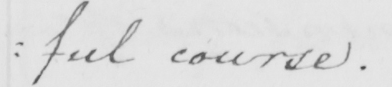What is written in this line of handwriting? : ful course . 